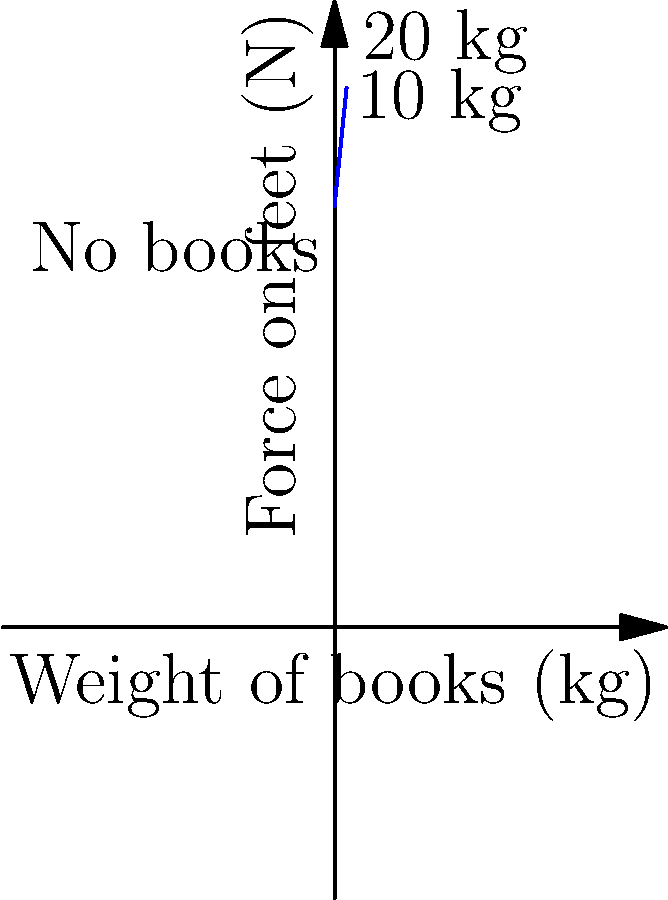In a library setting, how does the force distribution on a person's feet change when carrying different loads of books? Using the graph, calculate the additional force exerted on the feet when carrying 20 kg of books compared to no books. To solve this problem, we'll follow these steps:

1. Understand the graph:
   - The x-axis represents the weight of books in kg.
   - The y-axis represents the force on feet in Newtons (N).
   - The blue line shows how the force increases with book weight.

2. Identify the relevant points:
   - At 0 kg (no books), the force is 700 N.
   - At 20 kg of books, we need to read the corresponding y-value.

3. Read the force value at 20 kg:
   - Following the graph to 20 kg on the x-axis, we find the y-value is approximately 896 N.

4. Calculate the difference:
   - Additional force = Force with 20 kg - Force with 0 kg
   - Additional force = 896 N - 700 N = 196 N

5. Verify the result:
   - We can check this using the physics principle: Force = mass × acceleration due to gravity
   - Additional force = 20 kg × 9.8 m/s² = 196 N

This calculation confirms that carrying 20 kg of books increases the force on the feet by 196 N.
Answer: 196 N 